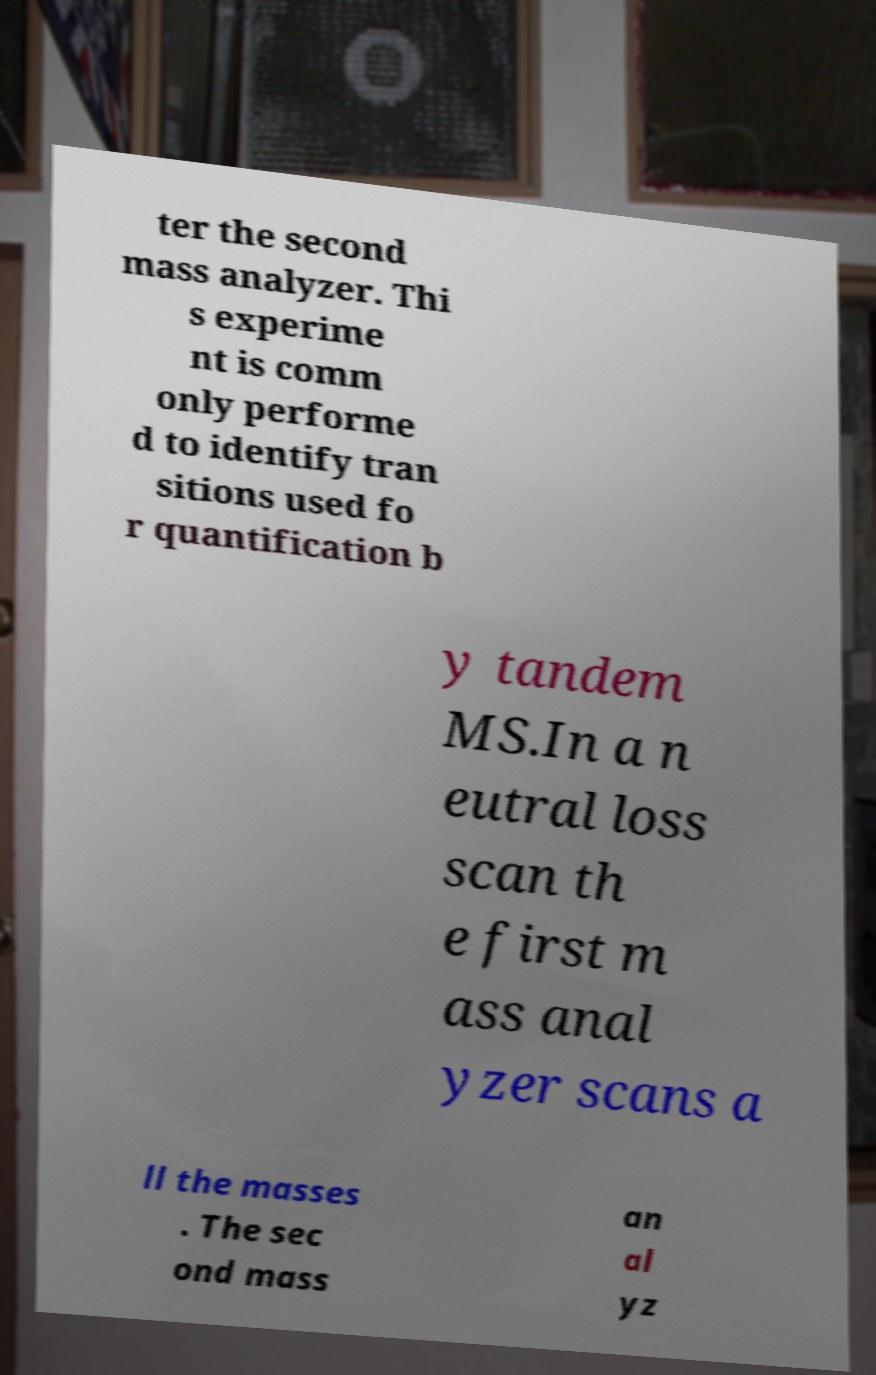Please identify and transcribe the text found in this image. ter the second mass analyzer. Thi s experime nt is comm only performe d to identify tran sitions used fo r quantification b y tandem MS.In a n eutral loss scan th e first m ass anal yzer scans a ll the masses . The sec ond mass an al yz 